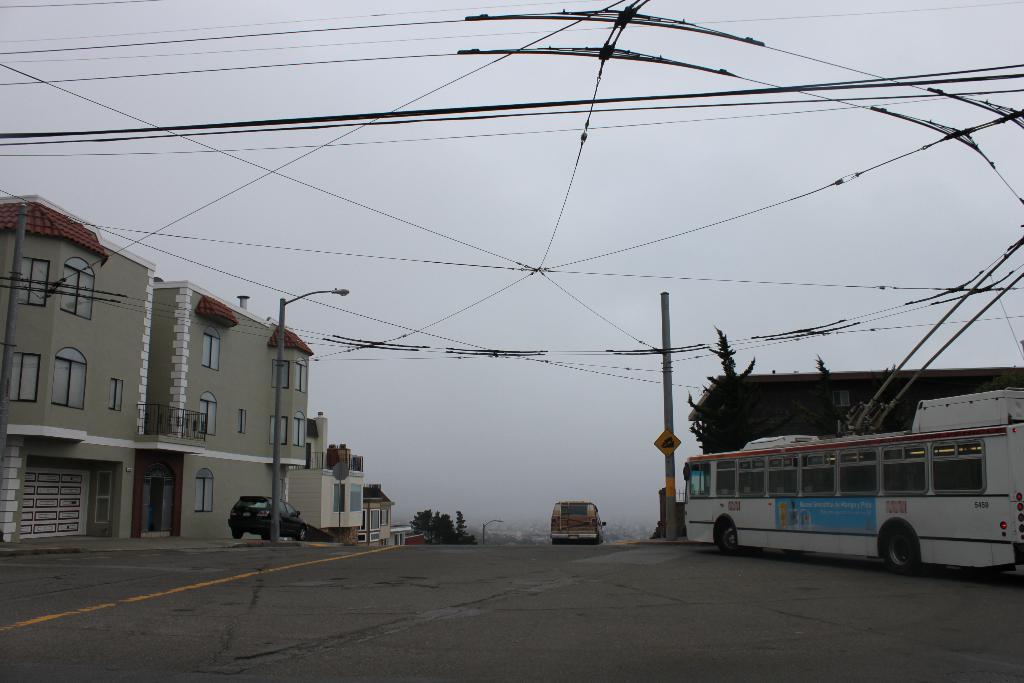Please provide a concise description of this image. In this image I can see few vehicles on the road and these are in different color. I can see two poles to the side of the road. To the left I can see the building. To the right there is a tree and another building. In the back I can see the sky. 